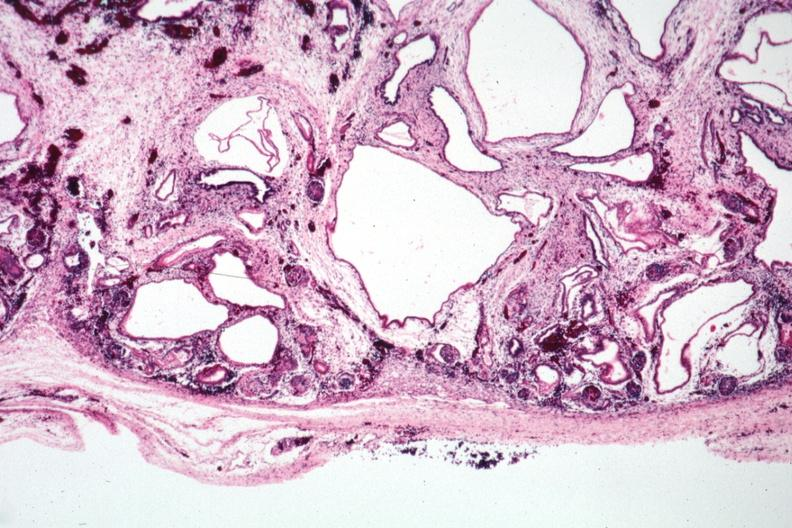what is present?
Answer the question using a single word or phrase. Kidney 